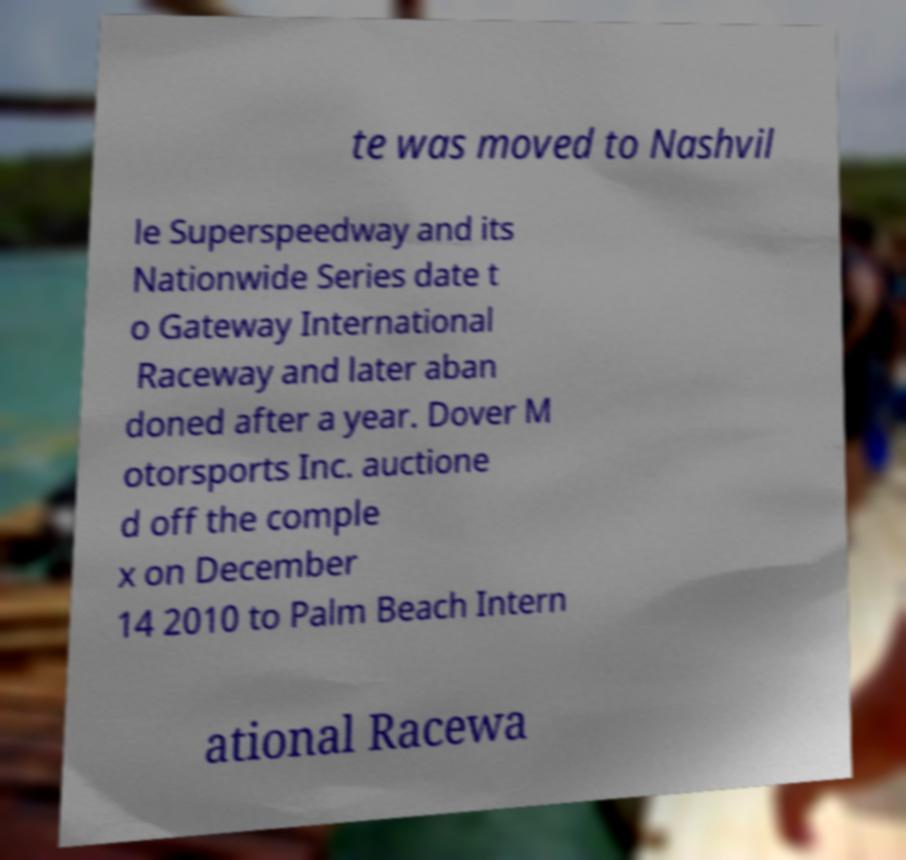What messages or text are displayed in this image? I need them in a readable, typed format. te was moved to Nashvil le Superspeedway and its Nationwide Series date t o Gateway International Raceway and later aban doned after a year. Dover M otorsports Inc. auctione d off the comple x on December 14 2010 to Palm Beach Intern ational Racewa 